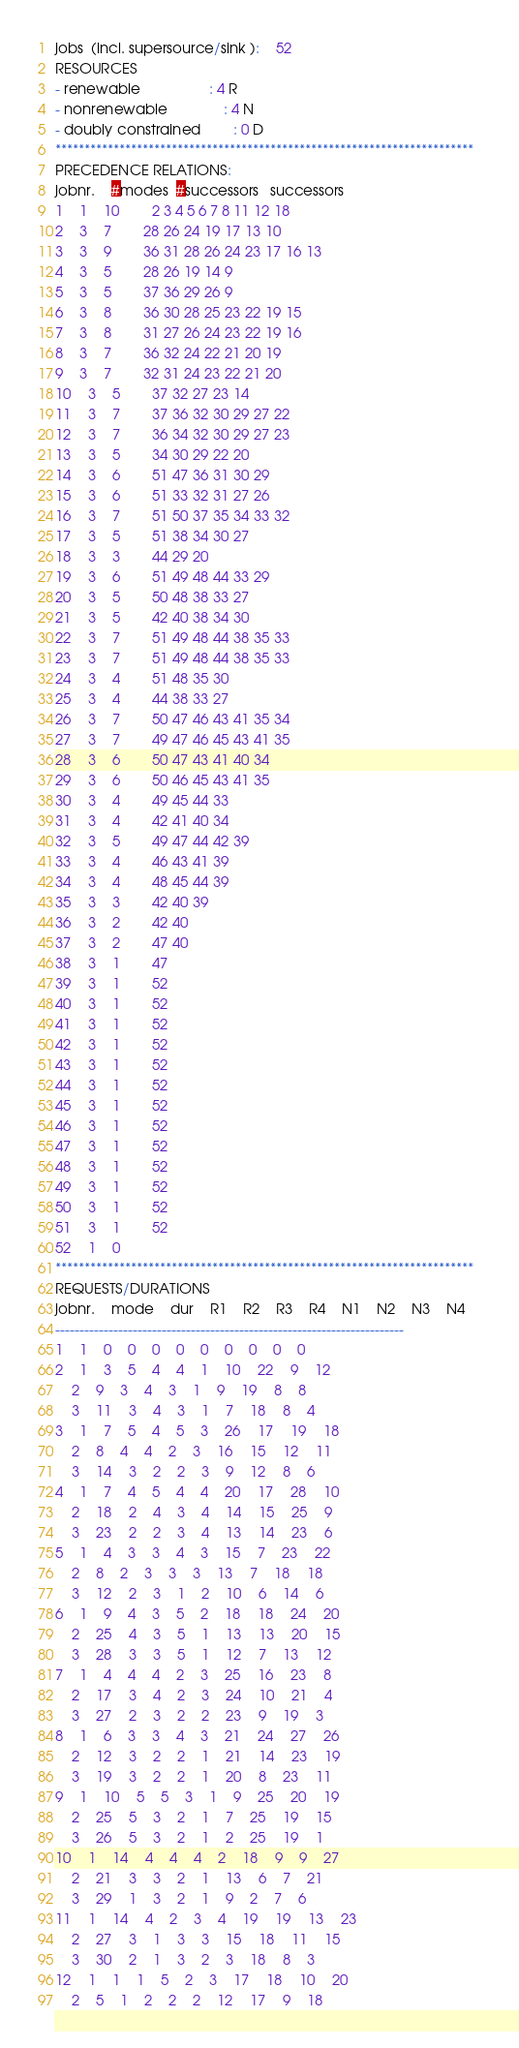Convert code to text. <code><loc_0><loc_0><loc_500><loc_500><_ObjectiveC_>jobs  (incl. supersource/sink ):	52
RESOURCES
- renewable                 : 4 R
- nonrenewable              : 4 N
- doubly constrained        : 0 D
************************************************************************
PRECEDENCE RELATIONS:
jobnr.    #modes  #successors   successors
1	1	10		2 3 4 5 6 7 8 11 12 18 
2	3	7		28 26 24 19 17 13 10 
3	3	9		36 31 28 26 24 23 17 16 13 
4	3	5		28 26 19 14 9 
5	3	5		37 36 29 26 9 
6	3	8		36 30 28 25 23 22 19 15 
7	3	8		31 27 26 24 23 22 19 16 
8	3	7		36 32 24 22 21 20 19 
9	3	7		32 31 24 23 22 21 20 
10	3	5		37 32 27 23 14 
11	3	7		37 36 32 30 29 27 22 
12	3	7		36 34 32 30 29 27 23 
13	3	5		34 30 29 22 20 
14	3	6		51 47 36 31 30 29 
15	3	6		51 33 32 31 27 26 
16	3	7		51 50 37 35 34 33 32 
17	3	5		51 38 34 30 27 
18	3	3		44 29 20 
19	3	6		51 49 48 44 33 29 
20	3	5		50 48 38 33 27 
21	3	5		42 40 38 34 30 
22	3	7		51 49 48 44 38 35 33 
23	3	7		51 49 48 44 38 35 33 
24	3	4		51 48 35 30 
25	3	4		44 38 33 27 
26	3	7		50 47 46 43 41 35 34 
27	3	7		49 47 46 45 43 41 35 
28	3	6		50 47 43 41 40 34 
29	3	6		50 46 45 43 41 35 
30	3	4		49 45 44 33 
31	3	4		42 41 40 34 
32	3	5		49 47 44 42 39 
33	3	4		46 43 41 39 
34	3	4		48 45 44 39 
35	3	3		42 40 39 
36	3	2		42 40 
37	3	2		47 40 
38	3	1		47 
39	3	1		52 
40	3	1		52 
41	3	1		52 
42	3	1		52 
43	3	1		52 
44	3	1		52 
45	3	1		52 
46	3	1		52 
47	3	1		52 
48	3	1		52 
49	3	1		52 
50	3	1		52 
51	3	1		52 
52	1	0		
************************************************************************
REQUESTS/DURATIONS
jobnr.	mode	dur	R1	R2	R3	R4	N1	N2	N3	N4	
------------------------------------------------------------------------
1	1	0	0	0	0	0	0	0	0	0	
2	1	3	5	4	4	1	10	22	9	12	
	2	9	3	4	3	1	9	19	8	8	
	3	11	3	4	3	1	7	18	8	4	
3	1	7	5	4	5	3	26	17	19	18	
	2	8	4	4	2	3	16	15	12	11	
	3	14	3	2	2	3	9	12	8	6	
4	1	7	4	5	4	4	20	17	28	10	
	2	18	2	4	3	4	14	15	25	9	
	3	23	2	2	3	4	13	14	23	6	
5	1	4	3	3	4	3	15	7	23	22	
	2	8	2	3	3	3	13	7	18	18	
	3	12	2	3	1	2	10	6	14	6	
6	1	9	4	3	5	2	18	18	24	20	
	2	25	4	3	5	1	13	13	20	15	
	3	28	3	3	5	1	12	7	13	12	
7	1	4	4	4	2	3	25	16	23	8	
	2	17	3	4	2	3	24	10	21	4	
	3	27	2	3	2	2	23	9	19	3	
8	1	6	3	3	4	3	21	24	27	26	
	2	12	3	2	2	1	21	14	23	19	
	3	19	3	2	2	1	20	8	23	11	
9	1	10	5	5	3	1	9	25	20	19	
	2	25	5	3	2	1	7	25	19	15	
	3	26	5	3	2	1	2	25	19	1	
10	1	14	4	4	4	2	18	9	9	27	
	2	21	3	3	2	1	13	6	7	21	
	3	29	1	3	2	1	9	2	7	6	
11	1	14	4	2	3	4	19	19	13	23	
	2	27	3	1	3	3	15	18	11	15	
	3	30	2	1	3	2	3	18	8	3	
12	1	1	1	5	2	3	17	18	10	20	
	2	5	1	2	2	2	12	17	9	18	</code> 